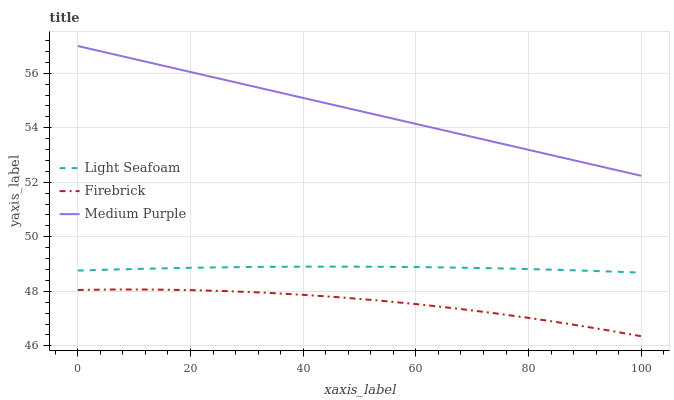Does Firebrick have the minimum area under the curve?
Answer yes or no. Yes. Does Medium Purple have the maximum area under the curve?
Answer yes or no. Yes. Does Light Seafoam have the minimum area under the curve?
Answer yes or no. No. Does Light Seafoam have the maximum area under the curve?
Answer yes or no. No. Is Medium Purple the smoothest?
Answer yes or no. Yes. Is Firebrick the roughest?
Answer yes or no. Yes. Is Light Seafoam the smoothest?
Answer yes or no. No. Is Light Seafoam the roughest?
Answer yes or no. No. Does Light Seafoam have the lowest value?
Answer yes or no. No. Does Medium Purple have the highest value?
Answer yes or no. Yes. Does Light Seafoam have the highest value?
Answer yes or no. No. Is Firebrick less than Light Seafoam?
Answer yes or no. Yes. Is Medium Purple greater than Firebrick?
Answer yes or no. Yes. Does Firebrick intersect Light Seafoam?
Answer yes or no. No. 